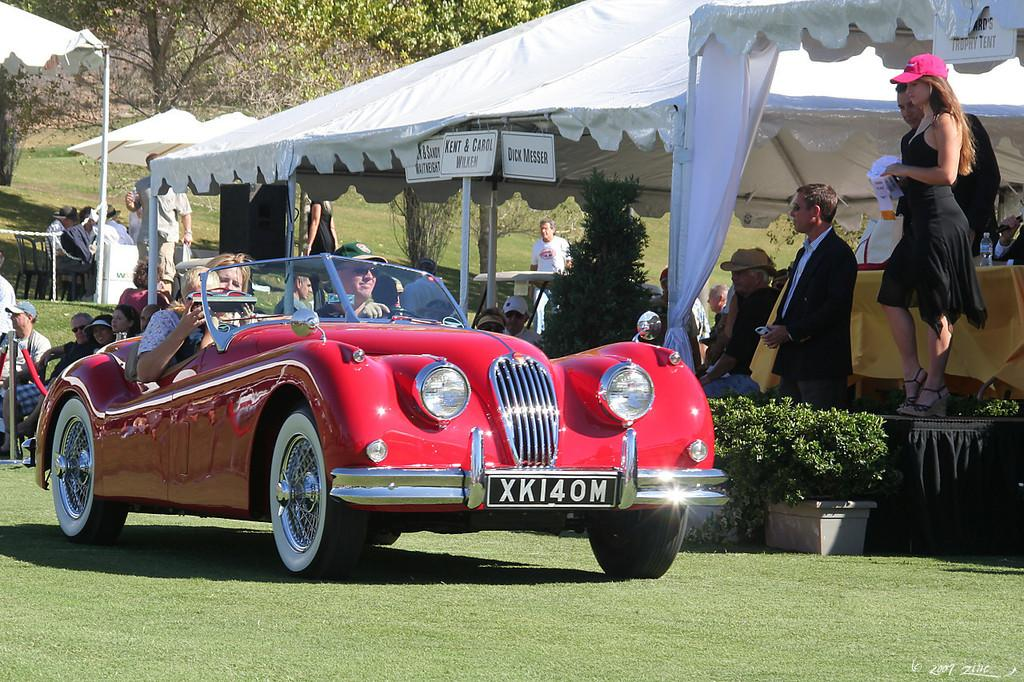What is the person in the image doing? There is a person driving a car in the image. What is the position of the other person in the image? There is a person standing in the image. What type of shelter is present in the image? There is a tent in the image. What can be seen in the background of the image? Trees are visible in the background of the image. What type of twig is being used to lift the tent in the image? There is no twig or lifting action involving the tent in the image. Where is the vase located in the image? There is no vase present in the image. 